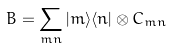Convert formula to latex. <formula><loc_0><loc_0><loc_500><loc_500>B = \sum _ { m n } | m \rangle \langle n | \otimes C _ { m n }</formula> 